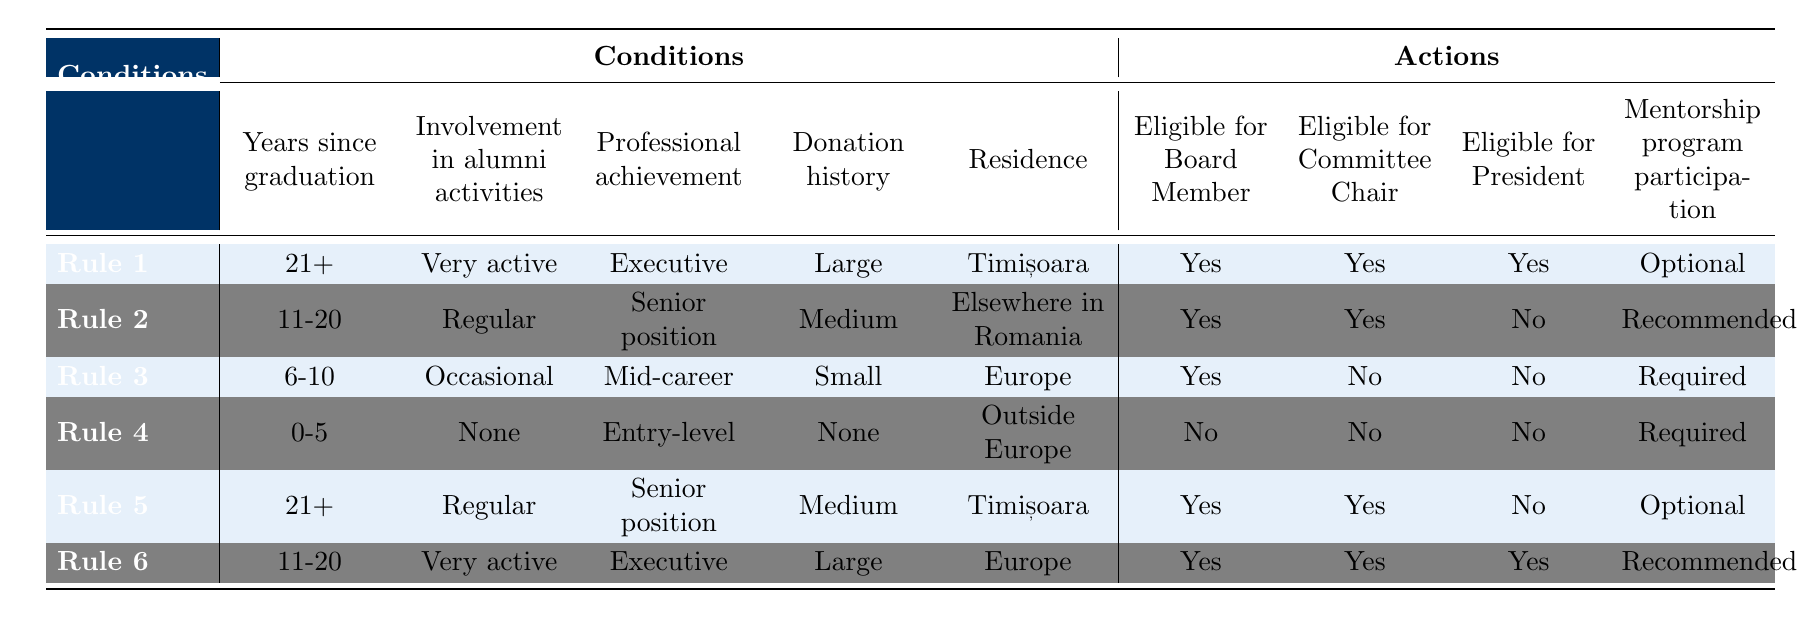What are the eligibility criteria for a Committee Chair for someone who has graduated more than 20 years ago? Based on Rule 1, a graduate who has graduated 21+ years ago and is Very active in alumni activities is eligible for a Committee Chair. Rule 5 also confirms this, where a graduation of 21+ years, Regular involvement, and Senior position leads to eligibility as well.
Answer: Yes Is a graduate with 6-10 years since graduation and Small donation history eligible for the President role? Referring to Rule 3, a graduate with 6-10 years of graduation, Occasional involvement, Mid-career achievement, and Small donation history is not eligible for the President role.
Answer: No How many rules indicate eligibility for the Board Member position? There are three rules indicating eligibility for the Board Member position (Rule 1, Rule 2, Rule 3, Rule 5, and Rule 6). Each of these rules shows 'Yes' for the Board Member eligibility. Therefore, the total count is 5.
Answer: 5 For a graduate who lives outside Europe, is participation in the mentorship program required? According to Rule 4, for a graduate with 0-5 years since graduation, None involvement, Entry-level position, and No donation history who resides Outside Europe, participation is required in the mentorship program. Therefore, it confirms that in this case, participation is indeed required.
Answer: Yes Can you summarize the eligibility for a graduate who is Very active, Executive, and lives in Europe and has graduated in the last 20 years? Looking at both Rule 2 and Rule 6, it becomes clear that a graduate with Regular involvement for 11-20 years, Senior position, Medium donation history, and residing in Europe results in eligibility for Board Member and Committee Chair roles, but not for the President. This aligns with Rule 6, meeting executive criteria leads all roles to be eligible.
Answer: Yes, eligible for all roles 